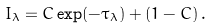<formula> <loc_0><loc_0><loc_500><loc_500>I _ { \lambda } = C \exp ( - \tau _ { \lambda } ) + ( 1 - C ) \, .</formula> 